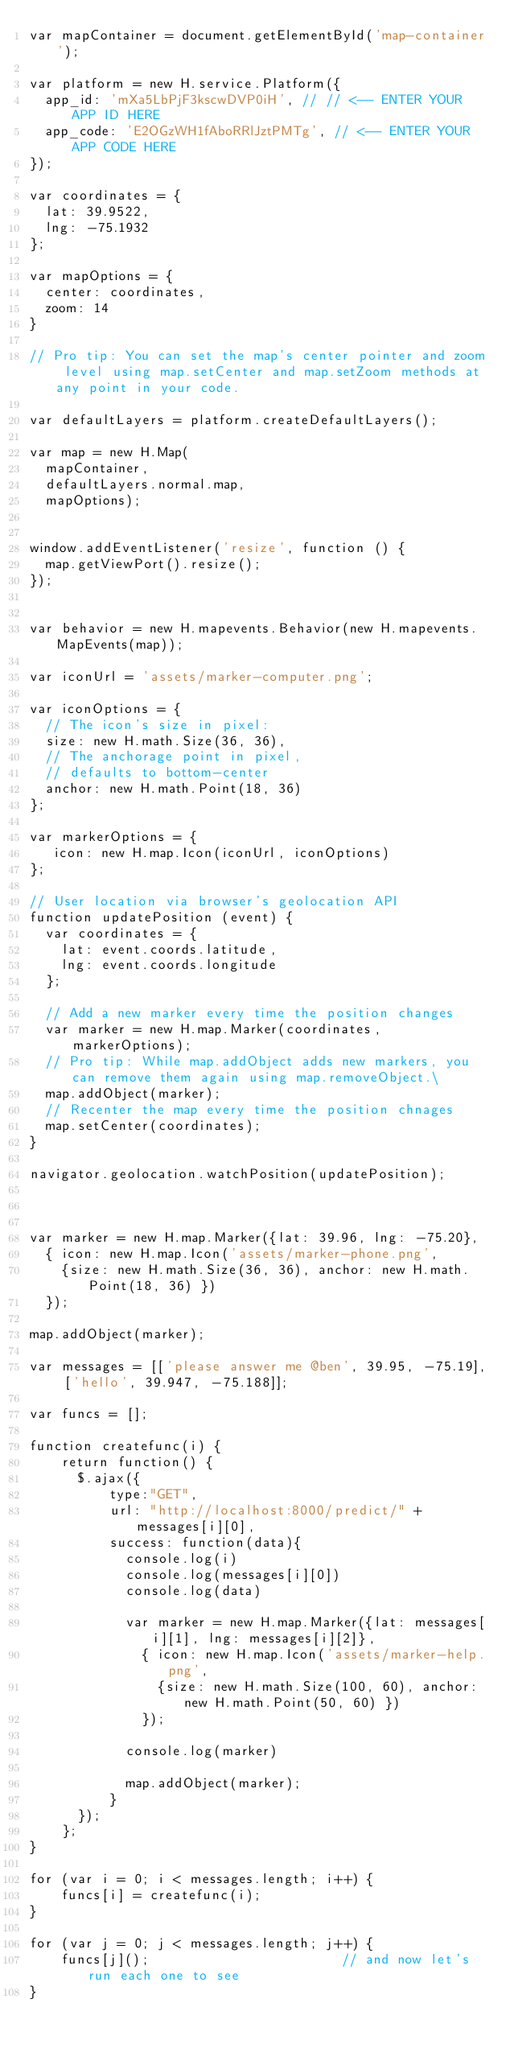<code> <loc_0><loc_0><loc_500><loc_500><_JavaScript_>var mapContainer = document.getElementById('map-container');

var platform = new H.service.Platform({
  app_id: 'mXa5LbPjF3kscwDVP0iH', // // <-- ENTER YOUR APP ID HERE
  app_code: 'E2OGzWH1fAboRRlJztPMTg', // <-- ENTER YOUR APP CODE HERE
});

var coordinates = {
  lat: 39.9522,
  lng: -75.1932
};

var mapOptions = {
  center: coordinates,
  zoom: 14
}

// Pro tip: You can set the map's center pointer and zoom level using map.setCenter and map.setZoom methods at any point in your code.

var defaultLayers = platform.createDefaultLayers();

var map = new H.Map(
  mapContainer,
  defaultLayers.normal.map,
  mapOptions);


window.addEventListener('resize', function () {
  map.getViewPort().resize();
});


var behavior = new H.mapevents.Behavior(new H.mapevents.MapEvents(map));

var iconUrl = 'assets/marker-computer.png';

var iconOptions = {
	// The icon's size in pixel:
  size: new H.math.Size(36, 36),
	// The anchorage point in pixel,
	// defaults to bottom-center
  anchor: new H.math.Point(18, 36)
};

var markerOptions = {
   icon: new H.map.Icon(iconUrl, iconOptions)
};

// User location via browser's geolocation API
function updatePosition (event) {
  var coordinates = {
    lat: event.coords.latitude,
    lng: event.coords.longitude
  };

  // Add a new marker every time the position changes
  var marker = new H.map.Marker(coordinates, markerOptions);
  // Pro tip: While map.addObject adds new markers, you can remove them again using map.removeObject.\
  map.addObject(marker);
  // Recenter the map every time the position chnages
  map.setCenter(coordinates);
}

navigator.geolocation.watchPosition(updatePosition);



var marker = new H.map.Marker({lat: 39.96, lng: -75.20},
  { icon: new H.map.Icon('assets/marker-phone.png',
    {size: new H.math.Size(36, 36), anchor: new H.math.Point(18, 36) })
  });

map.addObject(marker);

var messages = [['please answer me @ben', 39.95, -75.19], ['hello', 39.947, -75.188]];

var funcs = [];

function createfunc(i) {
    return function() {
      $.ajax({
          type:"GET",
          url: "http://localhost:8000/predict/" + messages[i][0],
          success: function(data){
            console.log(i)
            console.log(messages[i][0])
            console.log(data)

            var marker = new H.map.Marker({lat: messages[i][1], lng: messages[i][2]},
              { icon: new H.map.Icon('assets/marker-help.png',
                {size: new H.math.Size(100, 60), anchor: new H.math.Point(50, 60) })
              });

            console.log(marker)

            map.addObject(marker);
          }
      });
    };
}

for (var i = 0; i < messages.length; i++) {
    funcs[i] = createfunc(i);
}

for (var j = 0; j < messages.length; j++) {
    funcs[j]();                        // and now let's run each one to see
}
</code> 